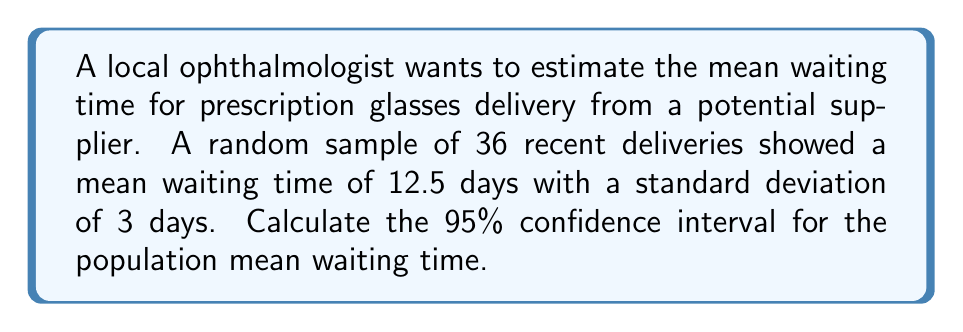Provide a solution to this math problem. To calculate the confidence interval, we'll follow these steps:

1) We have the following information:
   - Sample size: $n = 36$
   - Sample mean: $\bar{x} = 12.5$ days
   - Sample standard deviation: $s = 3$ days
   - Confidence level: 95% (α = 0.05)

2) The formula for the confidence interval is:

   $$ \text{CI} = \bar{x} \pm t_{\alpha/2} \cdot \frac{s}{\sqrt{n}} $$

3) For a 95% confidence interval with 35 degrees of freedom (n-1), the t-value is approximately 2.030 (from t-distribution table).

4) Calculate the margin of error:

   $$ \text{Margin of Error} = t_{\alpha/2} \cdot \frac{s}{\sqrt{n}} = 2.030 \cdot \frac{3}{\sqrt{36}} = 2.030 \cdot 0.5 = 1.015 $$

5) Calculate the lower and upper bounds of the confidence interval:

   Lower bound: $12.5 - 1.015 = 11.485$
   Upper bound: $12.5 + 1.015 = 13.515$

6) Round to two decimal places for practical interpretation.
Answer: (11.49, 13.52) days 